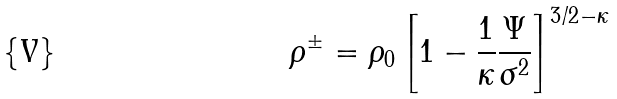Convert formula to latex. <formula><loc_0><loc_0><loc_500><loc_500>\rho ^ { \pm } = \rho _ { 0 } \left [ 1 - \frac { 1 } { \kappa } \frac { \Psi } { \sigma ^ { 2 } } \right ] ^ { 3 / 2 - \kappa }</formula> 